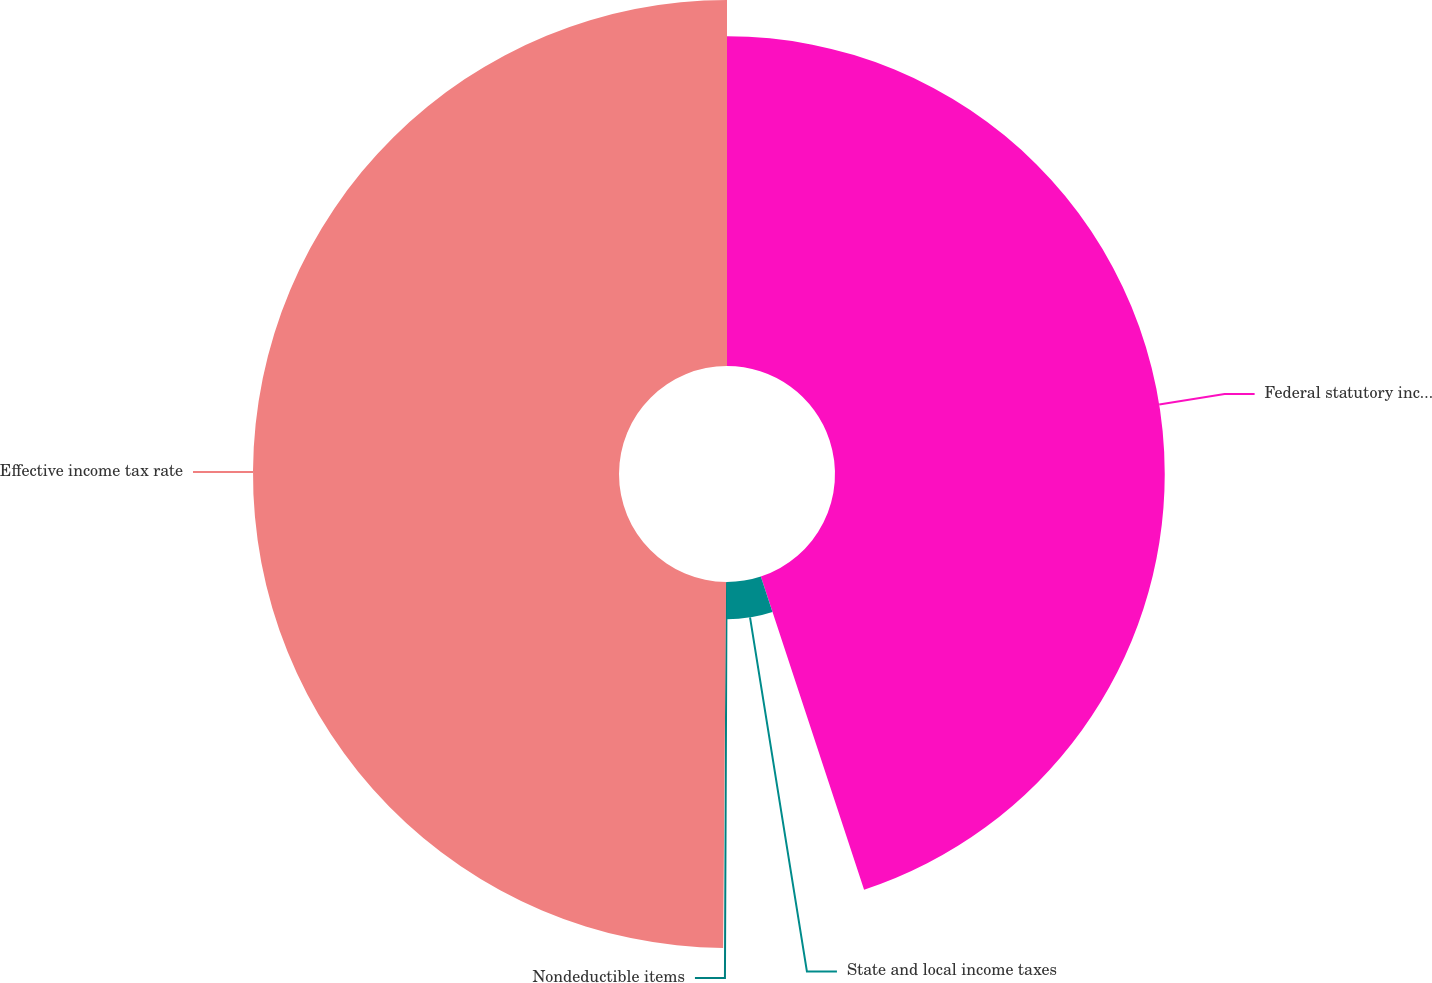<chart> <loc_0><loc_0><loc_500><loc_500><pie_chart><fcel>Federal statutory income tax<fcel>State and local income taxes<fcel>Nondeductible items<fcel>Effective income tax rate<nl><fcel>44.93%<fcel>5.07%<fcel>0.13%<fcel>49.87%<nl></chart> 